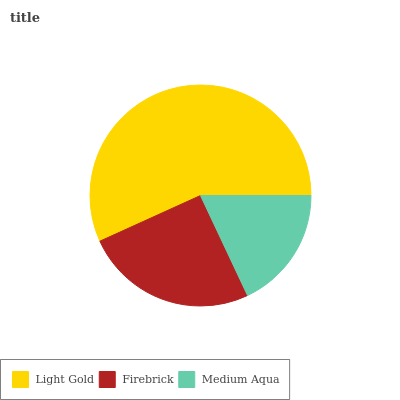Is Medium Aqua the minimum?
Answer yes or no. Yes. Is Light Gold the maximum?
Answer yes or no. Yes. Is Firebrick the minimum?
Answer yes or no. No. Is Firebrick the maximum?
Answer yes or no. No. Is Light Gold greater than Firebrick?
Answer yes or no. Yes. Is Firebrick less than Light Gold?
Answer yes or no. Yes. Is Firebrick greater than Light Gold?
Answer yes or no. No. Is Light Gold less than Firebrick?
Answer yes or no. No. Is Firebrick the high median?
Answer yes or no. Yes. Is Firebrick the low median?
Answer yes or no. Yes. Is Light Gold the high median?
Answer yes or no. No. Is Light Gold the low median?
Answer yes or no. No. 